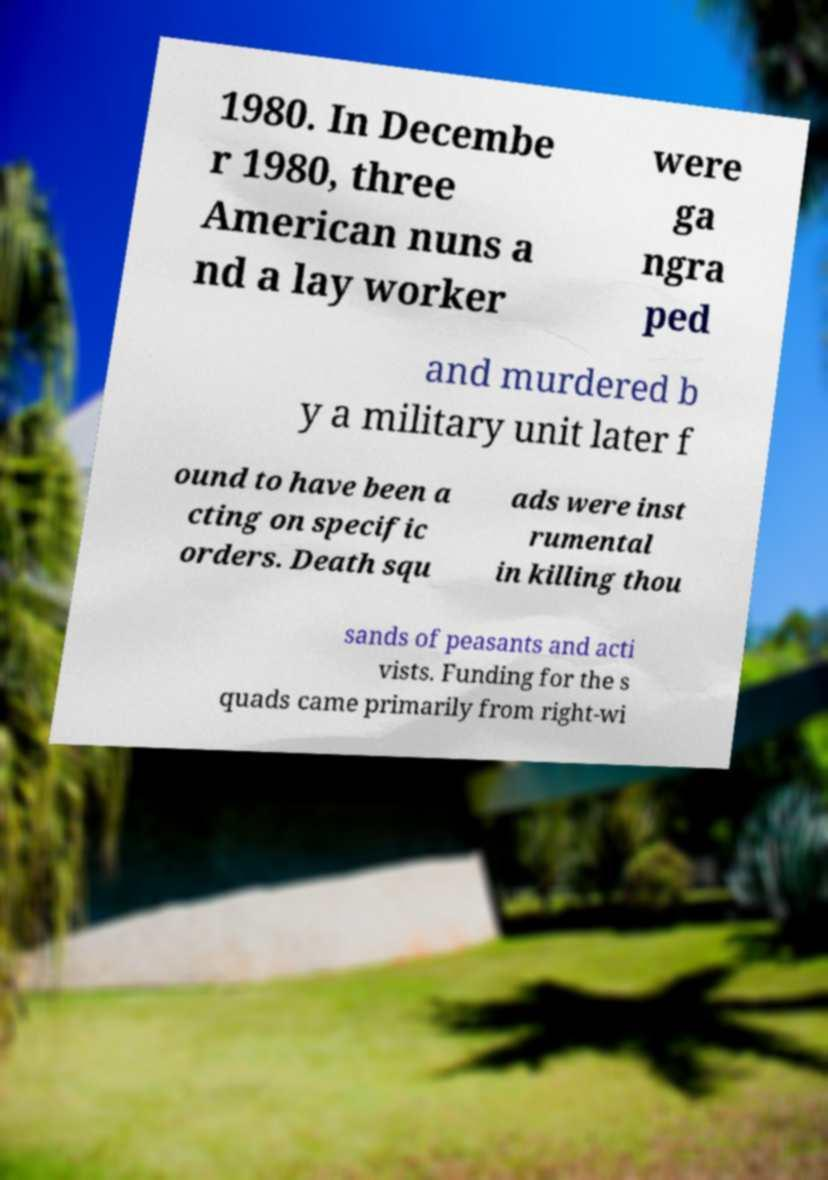Can you read and provide the text displayed in the image?This photo seems to have some interesting text. Can you extract and type it out for me? 1980. In Decembe r 1980, three American nuns a nd a lay worker were ga ngra ped and murdered b y a military unit later f ound to have been a cting on specific orders. Death squ ads were inst rumental in killing thou sands of peasants and acti vists. Funding for the s quads came primarily from right-wi 